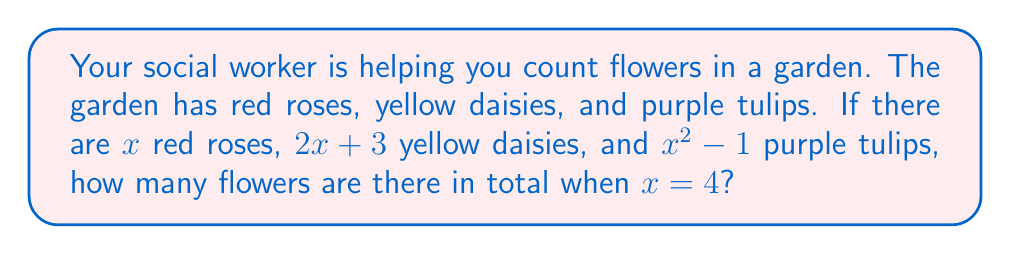Give your solution to this math problem. Let's break this down step-by-step:

1) We have three types of flowers:
   - Red roses: $x$
   - Yellow daisies: $2x + 3$
   - Purple tulips: $x^2 - 1$

2) To find the total number of flowers, we need to add these together:
   Total flowers = $x + (2x + 3) + (x^2 - 1)$

3) This gives us the polynomial: $x^2 + 3x + 2$

4) Now, we need to substitute $x = 4$ into this polynomial:

   $x^2 + 3x + 2$
   $= 4^2 + 3(4) + 2$
   $= 16 + 12 + 2$
   $= 30$

So, when $x = 4$, there are 30 flowers in total.
Answer: 30 flowers 